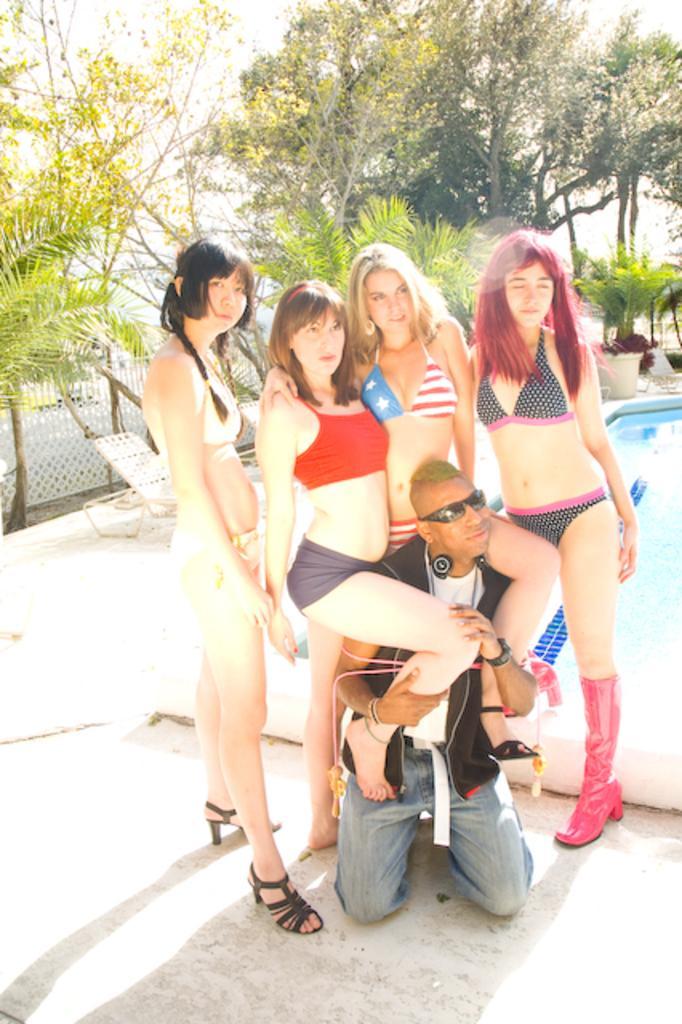How would you summarize this image in a sentence or two? In this image I can see group of people were four of them are women and one is man. Man is wearing black color of shades and holding two legs of two different girls. In the background I can see number of trees, swimming pool and chairs. 